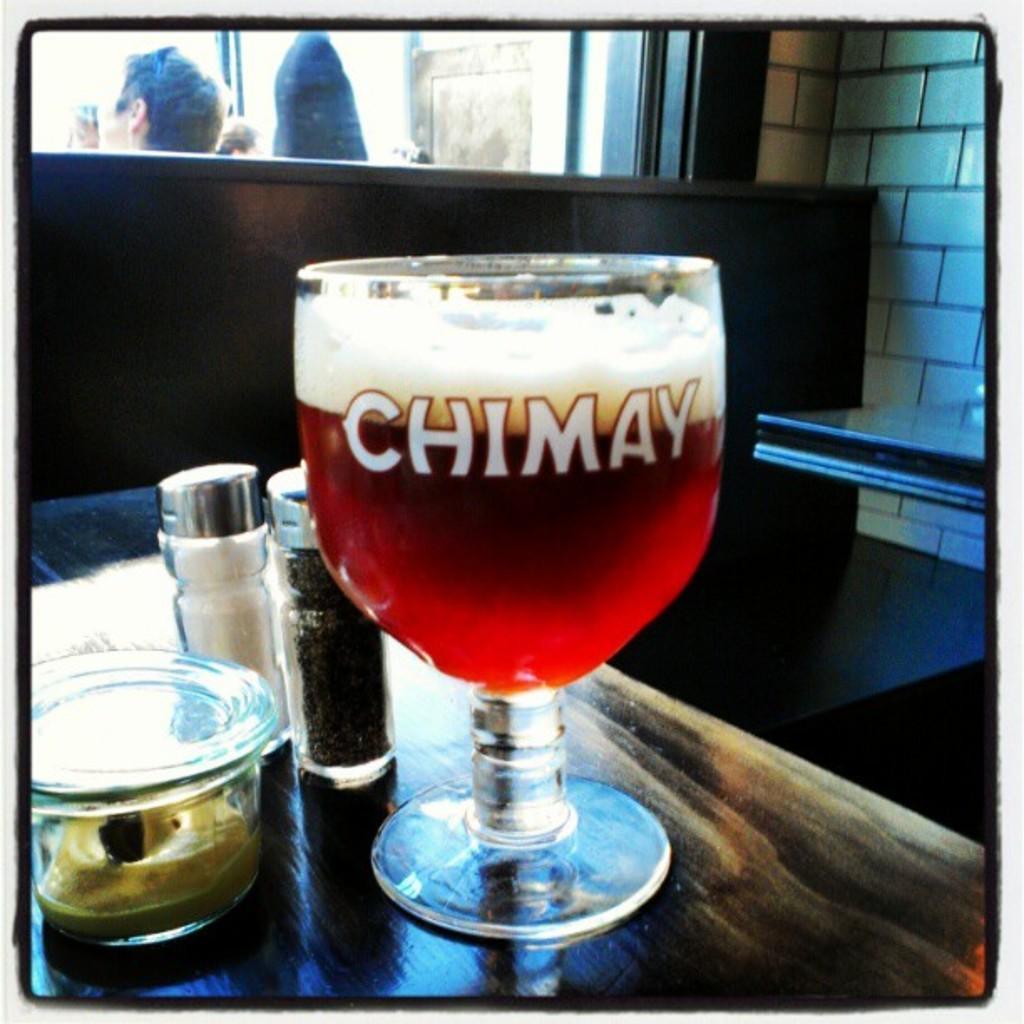How would you summarize this image in a sentence or two? In this image there are tables and we can see a glass containing wine, salt and pepper shakers and a bowl placed on the table. In the background we can see people and there is a wall. 